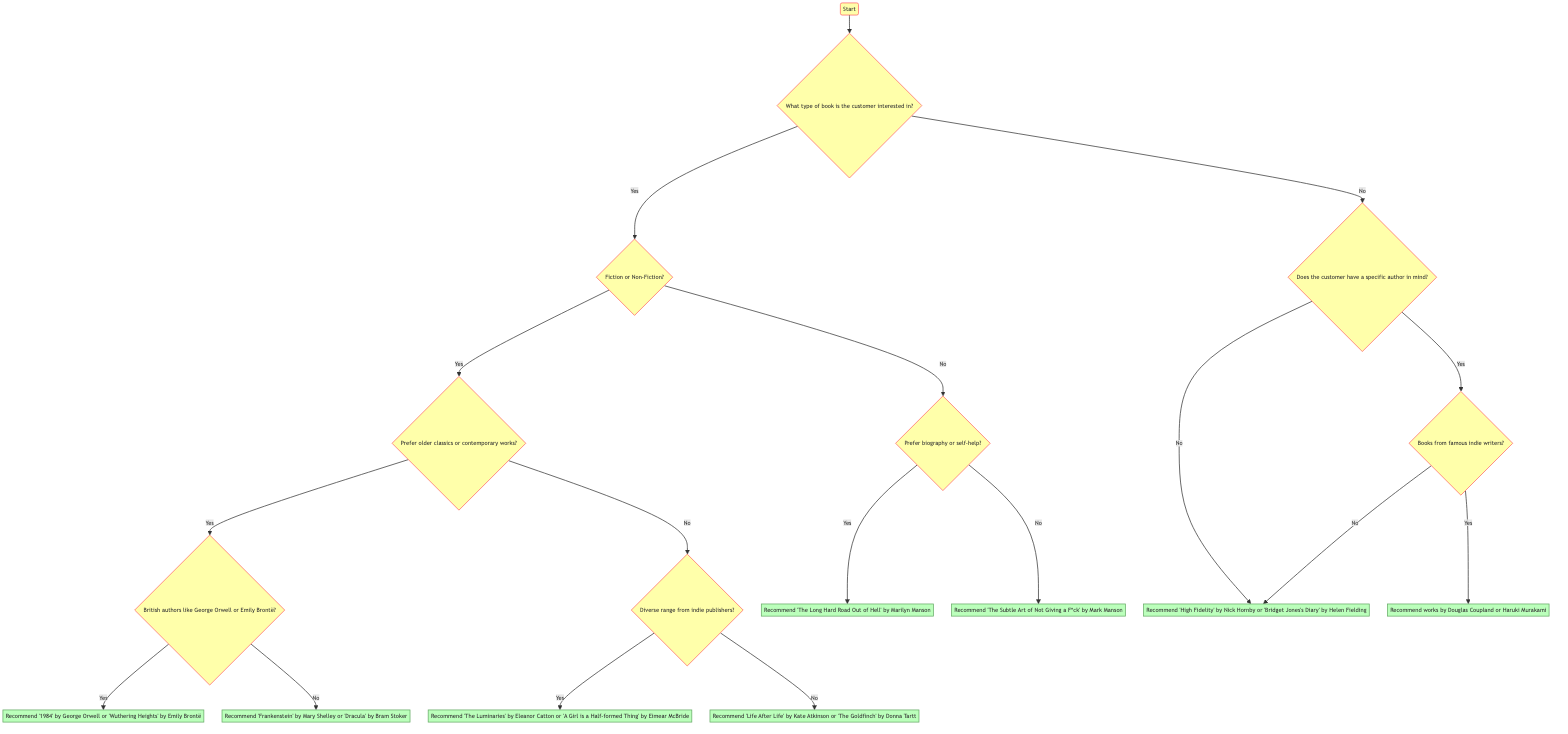What type of book does the customer show interest in? The diagram starts with the "Start" node, which asks about the type of book the customer is interested in. This is the first question in the flow.
Answer: What type of book is the customer interested in? What are the two main genres considered in the decision tree? Following the "What type of book is the customer interested in?" question, the diagram branches into "Fiction" and "Non-Fiction." These are the two main genres considered at this stage.
Answer: Fiction and Non-Fiction What do you recommend if the customer prefers biography? If the customer prefers biography during the "Non-Fiction" decision branch, the recommendation given is "The Long Hard Road Out of Hell" by Marilyn Manson. This falls under the node for Non-Fiction leading to a biographical choice.
Answer: Recommend 'The Long Hard Road Out of Hell' by Marilyn Manson How does the diagram respond if the customer prefers older classics? Choosing "Fiction" and then "Older classics" leads to a further question about British authors. If the customer chooses "Yes" here, the recommendation is for either "1984" by George Orwell or "Wuthering Heights" by Emily Brontë.
Answer: Recommend '1984' by George Orwell or 'Wuthering Heights' by Emily Brontë If a customer is looking for works by famous indie writers, what would be the recommendation? When the customer expresses interest in a specific author and chooses "Yes" for famous indie writers, the recommendation node states to suggest works by Douglas Coupland or Haruki Murakami.
Answer: Recommend works by Douglas Coupland or Haruki Murakami What is the total number of end recommendation nodes in the diagram? The diagram contains a total of eight end recommendation nodes. Each terminal point is a unique literature suggestion leading from the decision questions.
Answer: Eight What happens if the customer does not have a specific author in mind? If the customer answers "No" about having a specific author in mind, the decision flows to recommending broader selections, leading to suggestions like "High Fidelity" by Nick Hornby or "Bridget Jones's Diary" by Helen Fielding.
Answer: Recommend 'High Fidelity' by Nick Hornby or 'Bridget Jones's Diary' by Helen Fielding Is there a recommendation for contemporary works? Yes, if the customer prefers contemporary works after selecting "Fiction" and then "No" for classics, they are suggested to consider titles from indie publishers, leading towards recommendations of two specific titles.
Answer: Recommend 'The Luminaries' by Eleanor Catton or 'A Girl is a Half-formed Thing' by Eimear McBride 